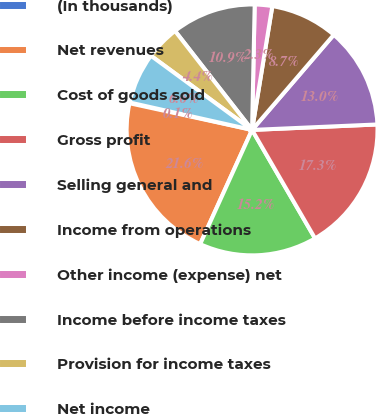Convert chart. <chart><loc_0><loc_0><loc_500><loc_500><pie_chart><fcel>(In thousands)<fcel>Net revenues<fcel>Cost of goods sold<fcel>Gross profit<fcel>Selling general and<fcel>Income from operations<fcel>Other income (expense) net<fcel>Income before income taxes<fcel>Provision for income taxes<fcel>Net income<nl><fcel>0.1%<fcel>21.62%<fcel>15.16%<fcel>17.32%<fcel>13.01%<fcel>8.71%<fcel>2.25%<fcel>10.86%<fcel>4.4%<fcel>6.56%<nl></chart> 